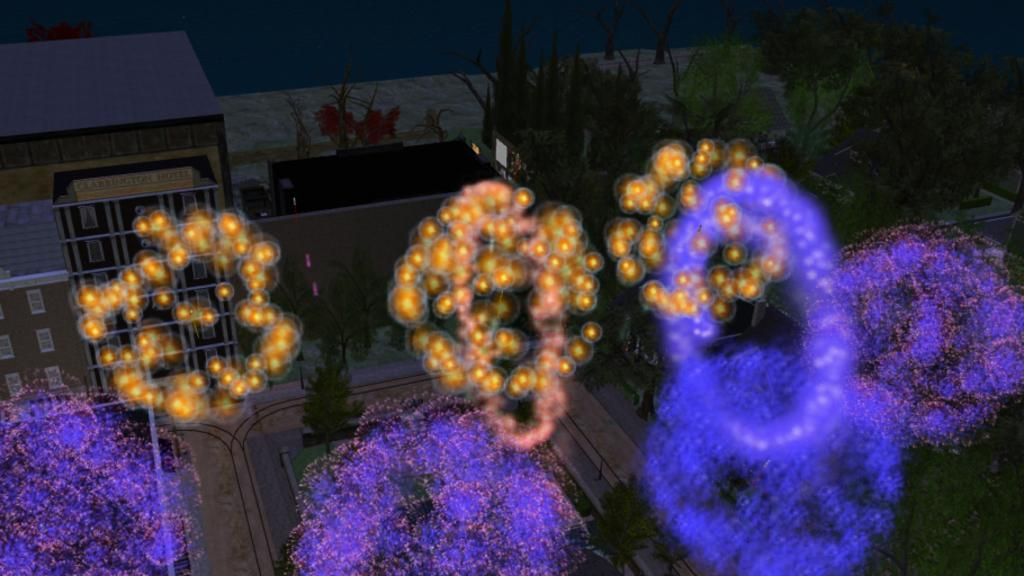What type of animated objects are present in the picture? There are animated plants, trees, a screen, a house, and lights in the picture. Can you describe the animated screen in the picture? The animated screen is a part of the image, but its specific features cannot be determined from the provided facts. What is the setting of the animated house in the picture? The setting of the animated house cannot be determined from the provided facts. Are there any animated objects that emit light in the picture? Yes, there are animated lights in the picture. What time of day is depicted in the picture, given the presence of animated morning light? There is no mention of morning light or any specific time of day in the provided facts, so it cannot be determined from the image. 